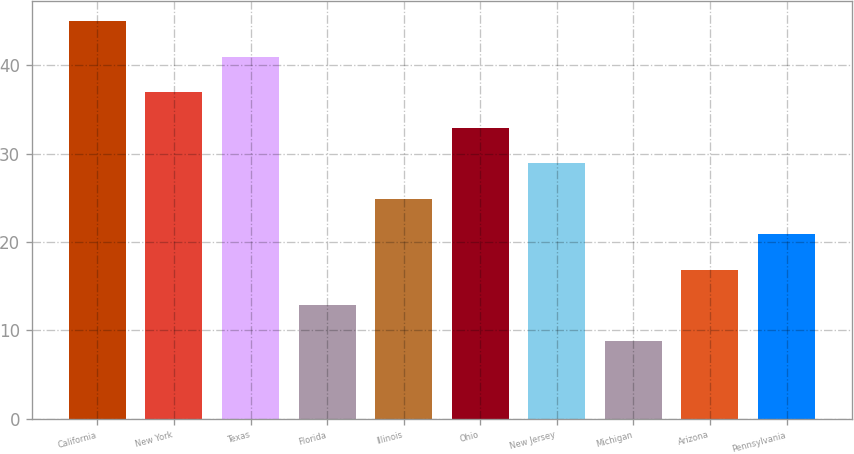Convert chart. <chart><loc_0><loc_0><loc_500><loc_500><bar_chart><fcel>California<fcel>New York<fcel>Texas<fcel>Florida<fcel>Illinois<fcel>Ohio<fcel>New Jersey<fcel>Michigan<fcel>Arizona<fcel>Pennsylvania<nl><fcel>45.02<fcel>36.98<fcel>41<fcel>12.86<fcel>24.92<fcel>32.96<fcel>28.94<fcel>8.84<fcel>16.88<fcel>20.9<nl></chart> 